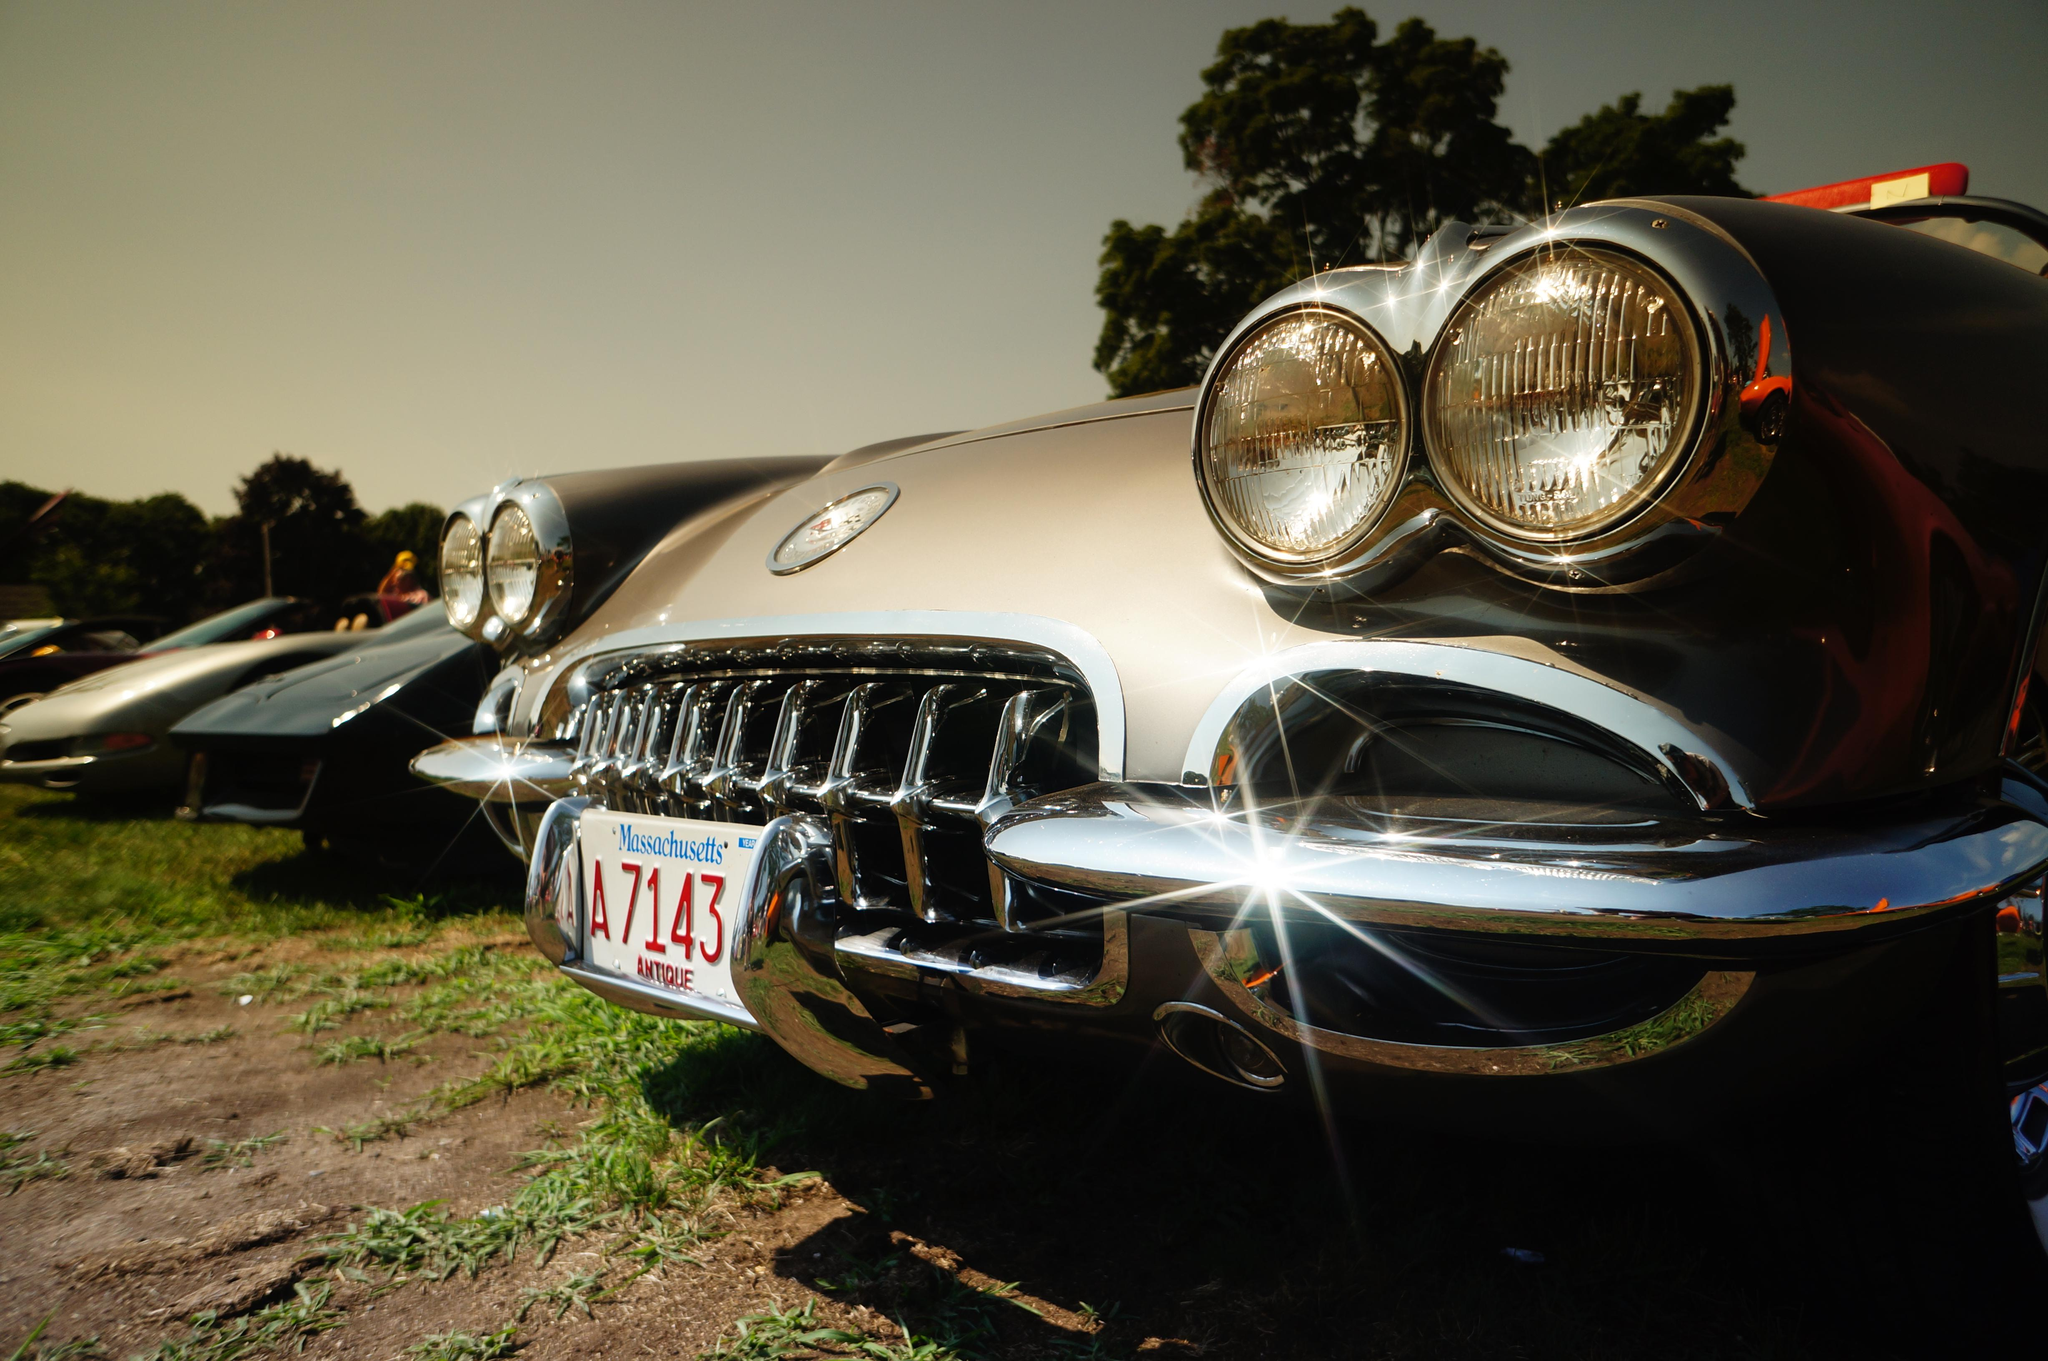What type of vehicle is the main subject in the image? There is a vintage car in the image. What is the surface on which the vintage car is placed? The vintage car is on a grass surface. Are there any other vehicles in the image? Yes, there are other cars in the image. Can you describe the person standing beside the vintage car? A person is standing beside the vintage car. What can be seen in the background of the image? There are trees and the sky visible in the background of the image. What color is the sweater worn by the person standing beside the vintage car? There is no information about the person's clothing in the image, so we cannot determine the color of any sweater they might be wearing. 